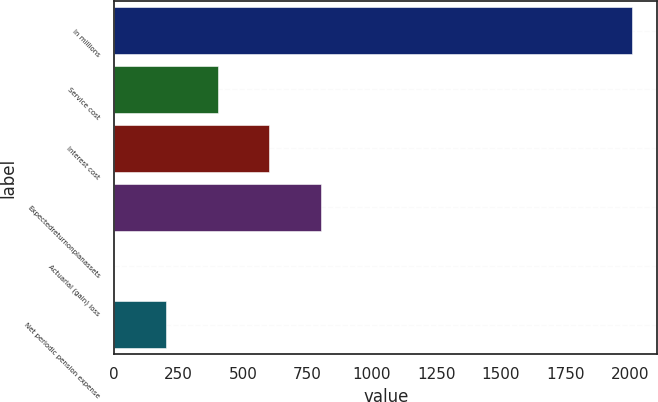Convert chart. <chart><loc_0><loc_0><loc_500><loc_500><bar_chart><fcel>In millions<fcel>Service cost<fcel>Interest cost<fcel>Expectedreturnonplanassets<fcel>Actuarial (gain) loss<fcel>Net periodic pension expense<nl><fcel>2007<fcel>402.2<fcel>602.8<fcel>803.4<fcel>1<fcel>201.6<nl></chart> 